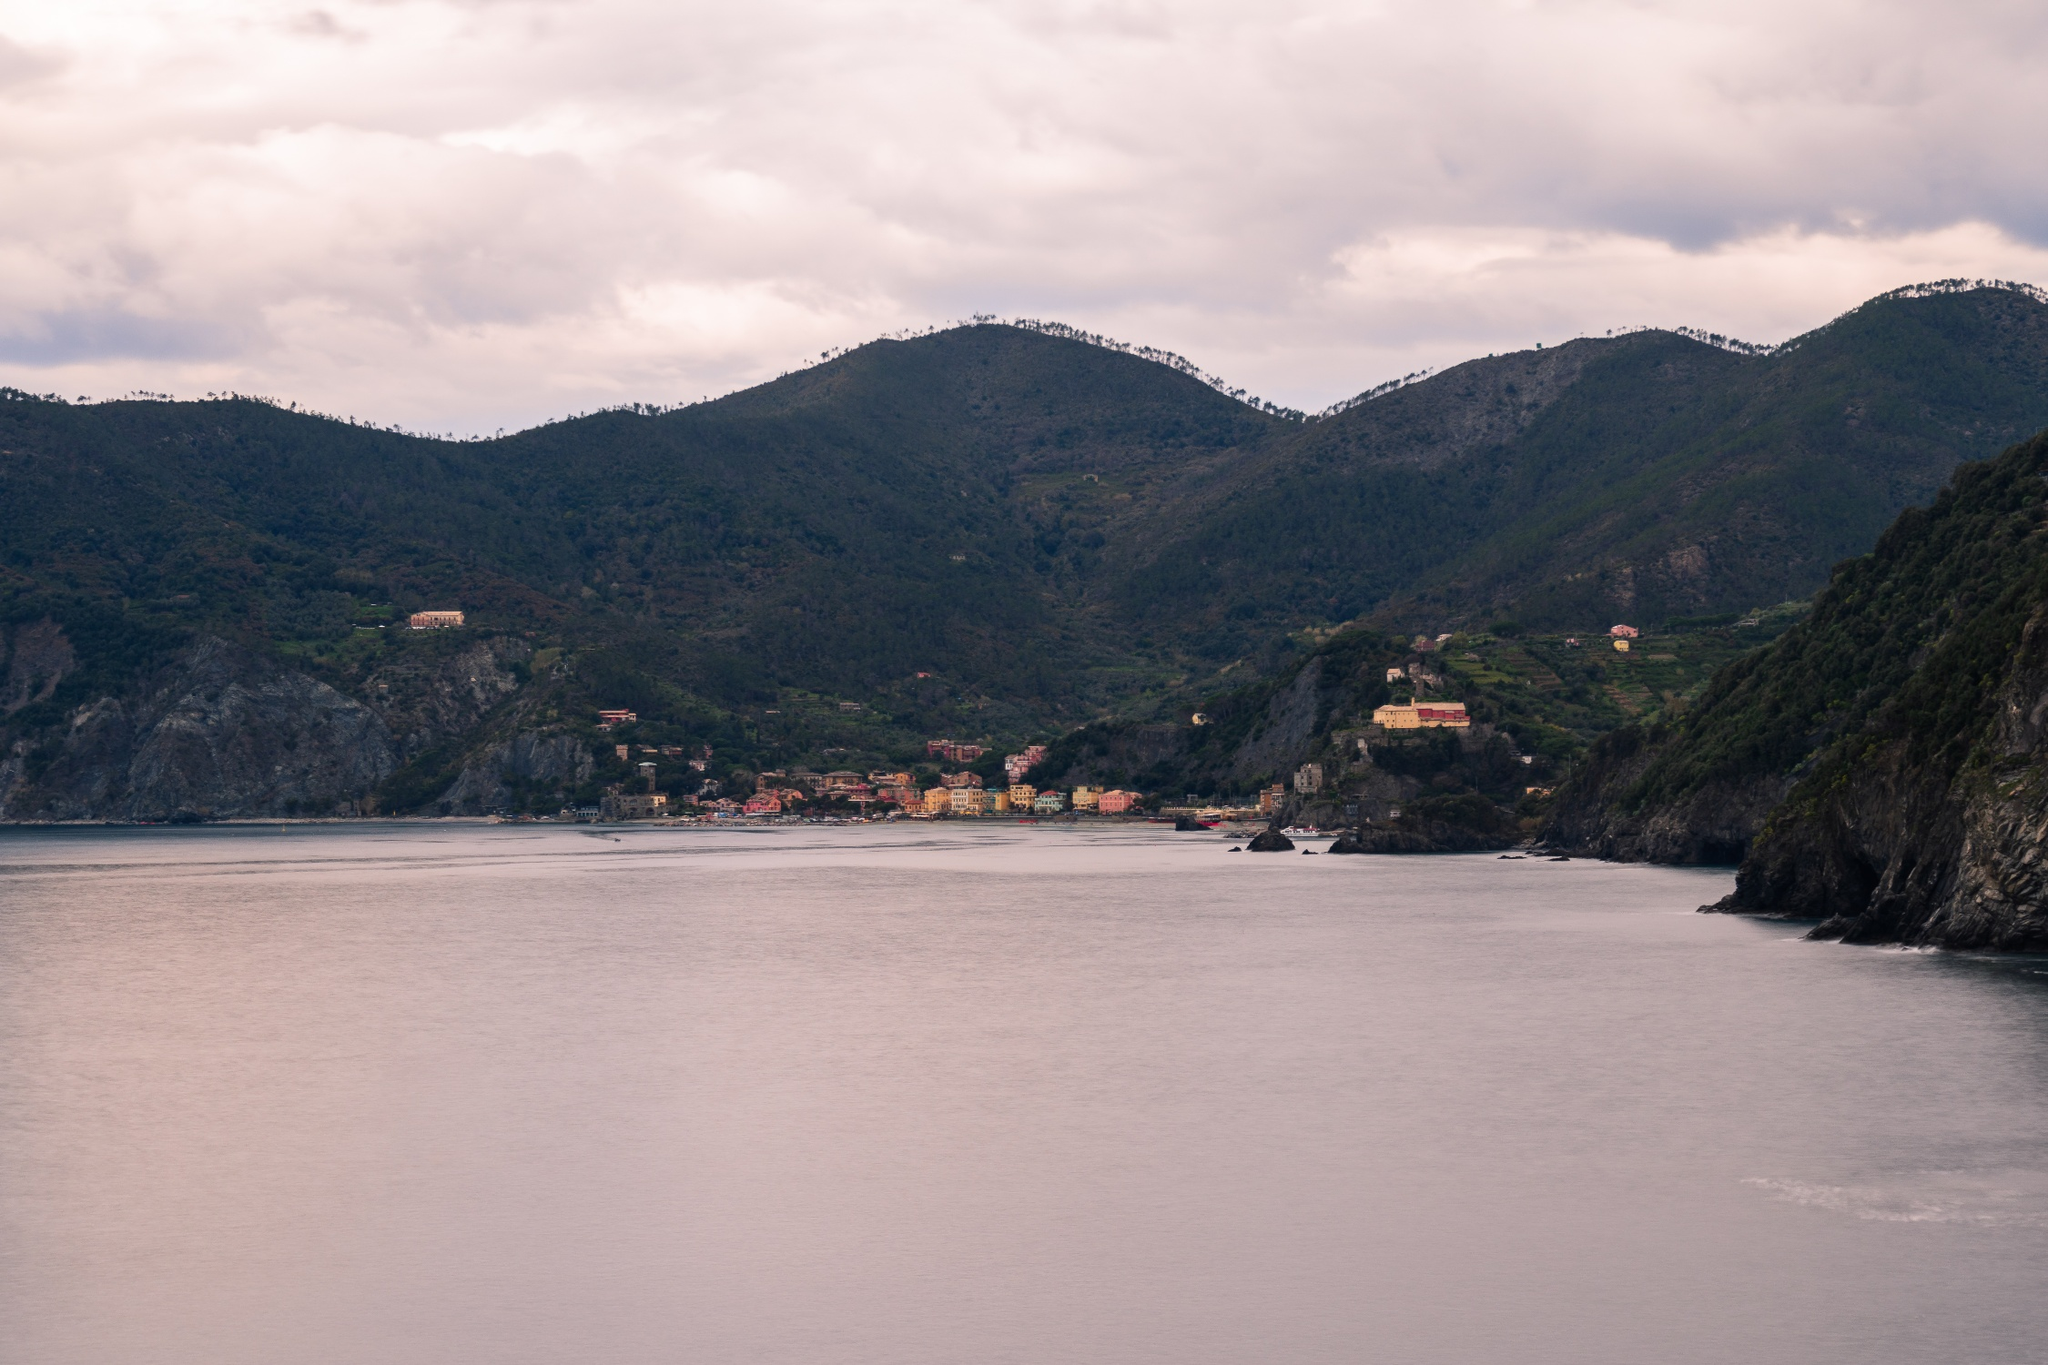What's happening in the scene? The image depicts a beautiful coastal town that appears to be peacefully situated on the edge of a peninsula surrounded by calm seas. The town, with its vibrantly colored buildings, creates an aesthetically pleasing contrast with the lush, green hills and rugged cliffs that frame it. The tranquil sea in the foreground stretches towards the horizon, reflecting the soft, overcast sky above. The scene encapsulates a serene and picturesque moment, likely during a calm and quiet day. 